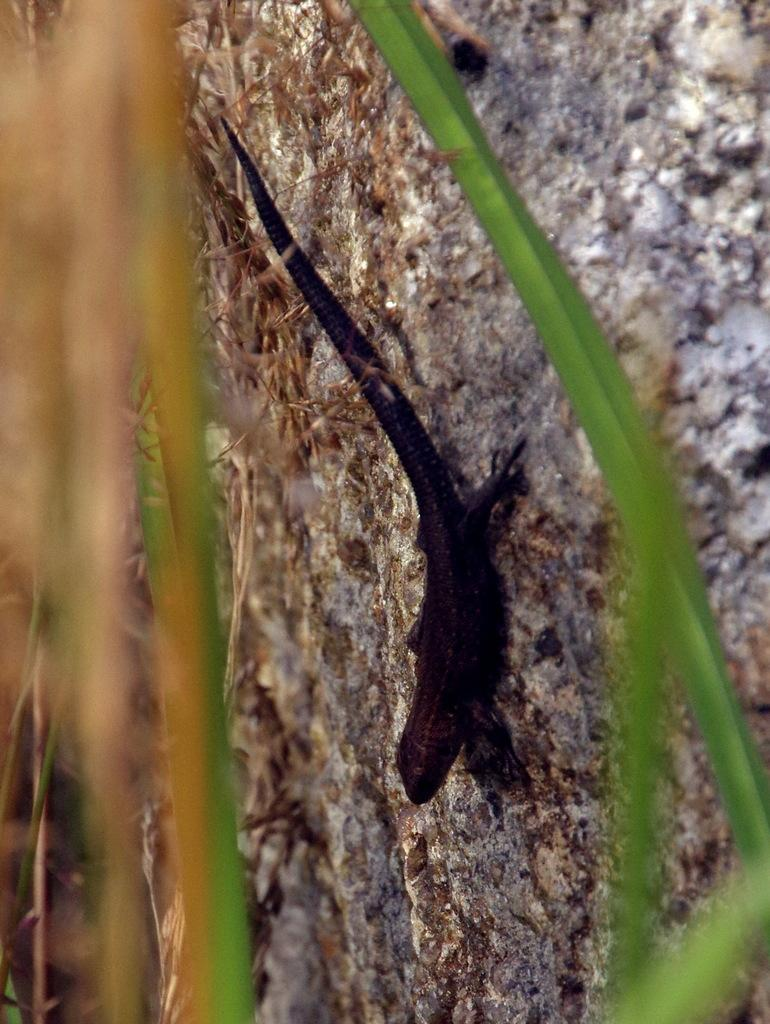What type of animal is in the image? There is a black reptile in the image. What is the reptile resting on? The reptile is on a grey surface. What type of vegetation is present in the image? There are green leaves visible in the image. Can you see any steam coming from the reptile in the image? There is no steam present in the image. What is the chance of the reptile catching a fish in the image? There is no fish or water visible in the image, so it is not possible to determine the reptile's chances of catching a fish. 